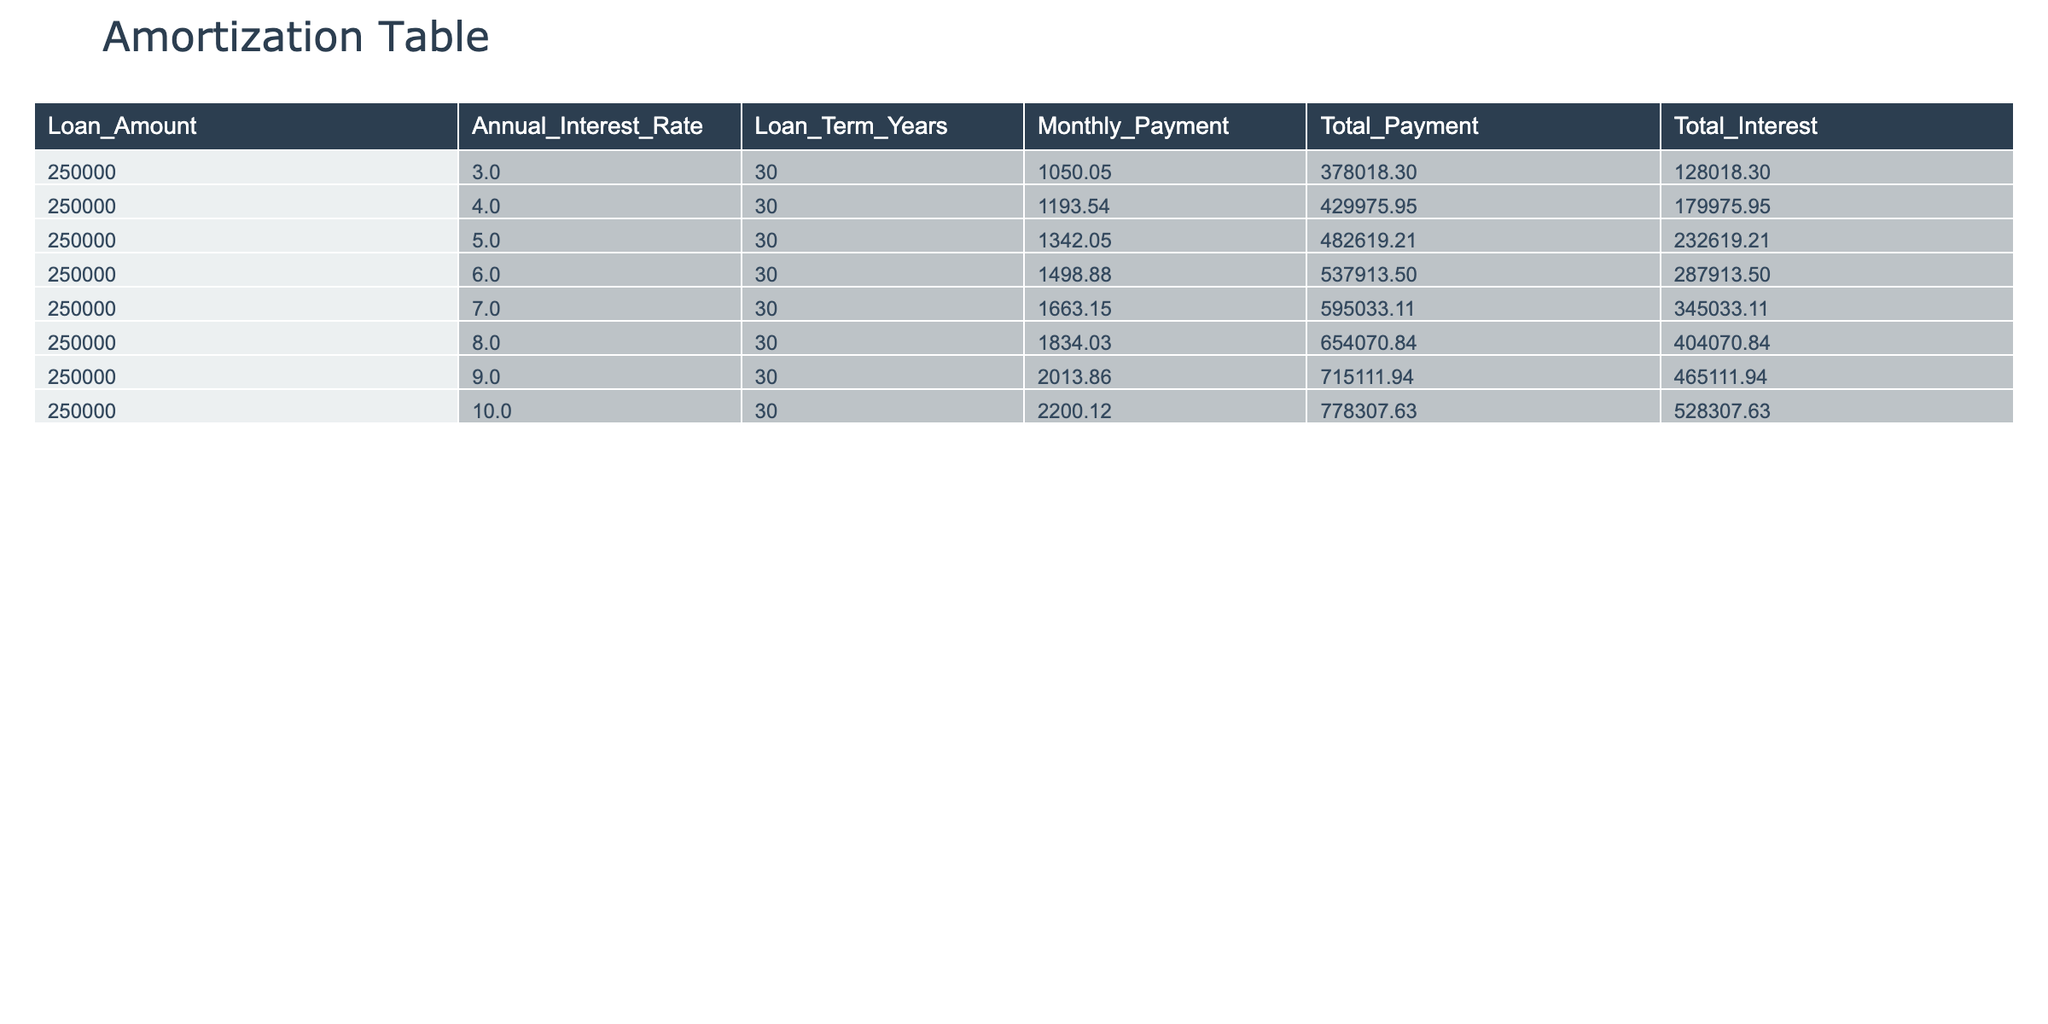What is the monthly payment for a loan with an annual interest rate of 4%? The table shows the monthly payment corresponding to each annual interest rate. For an interest rate of 4.0%, the table lists the monthly payment as 1193.54.
Answer: 1193.54 What is the total payment for a loan with an interest rate of 6%? Referring to the table, the total payment for the interest rate of 6.0% is indicated as 537913.50.
Answer: 537913.50 How much total interest will be paid over the life of a 30-year loan at a 7% interest rate? The total interest for the 7.0% interest rate is found directly in the table, which states it is 345033.11.
Answer: 345033.11 What is the difference in total payment between a loan at 5% and a loan at 8%? To find the difference, we take the total payment for 5.0% (482619.21) and subtract the total payment for 8.0% (654070.84): 482619.21 - 654070.84 = -171451.63.
Answer: -171451.63 Is the total interest paid on a loan at 10% greater than that of a loan at 3%? The total interest for a loan at 10.0% is 528307.63, while at 3.0% it is 128018.30. Since 528307.63 is greater than 128018.30, the answer is yes.
Answer: Yes What is the average monthly payment across all interest rates listed? To calculate the average, sum all monthly payments: (1050.05 + 1193.54 + 1342.05 + 1498.88 + 1663.15 + 1834.03 + 2013.86 + 2200.12) = 11792.13. Then divide this by the number of rates (8): 11792.13 / 8 = 1474.01.
Answer: 1474.01 How much more total interest is paid at 9% compared to 6%? The total interest at 9.0% is 465111.94 and at 6.0% is 287913.50. The difference is calculated by subtracting: 465111.94 - 287913.50 = 177198.44.
Answer: 177198.44 What is the highest monthly payment recorded in the table? Scanning through the monthly payment values, the highest one occurs at an interest rate of 10.0%, which is 2200.12.
Answer: 2200.12 Does a loan with a higher interest rate always result in a higher total payment? Looking at the table, it is evident that as the interest rate increases from 3.0% to 10.0%, the total payment also increases from 378018.30 to 778307.63. Therefore, this statement is true.
Answer: Yes 